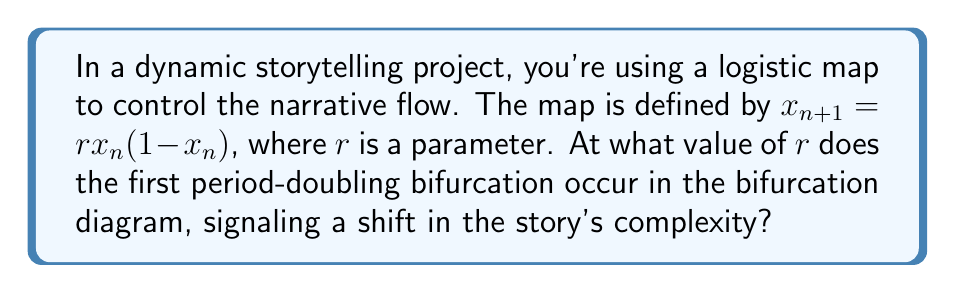Solve this math problem. To find the first period-doubling bifurcation in the logistic map, we need to follow these steps:

1) The logistic map is given by $x_{n+1} = rx_n(1-x_n)$.

2) At equilibrium, $x_{n+1} = x_n = x^*$. So, we can write:
   $x^* = rx^*(1-x^*)$

3) Solving this equation:
   $x^* = rx^* - rx^{*2}$
   $rx^{*2} - rx^* + x^* = 0$
   $x^*(rx^* - r + 1) = 0$

4) The non-zero solution is:
   $x^* = 1 - \frac{1}{r}$

5) To find the stability of this fixed point, we calculate the derivative of the map:
   $\frac{df}{dx} = r(1-2x)$

6) At the fixed point:
   $\frac{df}{dx}|_{x^*} = r(1-2(1-\frac{1}{r})) = r(1-2+\frac{2}{r}) = 2-r$

7) The fixed point loses stability when $|\frac{df}{dx}|_{x^*}| = 1$. So:
   $|2-r| = 1$

8) Solving this equation:
   $2-r = 1$ or $2-r = -1$
   $r = 1$ or $r = 3$

9) The first period-doubling bifurcation occurs at $r = 3$.
Answer: $r = 3$ 